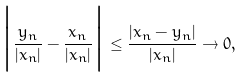Convert formula to latex. <formula><loc_0><loc_0><loc_500><loc_500>\Big { | } \frac { y _ { n } } { | x _ { n } | } - \frac { x _ { n } } { | x _ { n } | } \Big { | } \leq \frac { | x _ { n } - y _ { n } | } { | x _ { n } | } \to 0 ,</formula> 